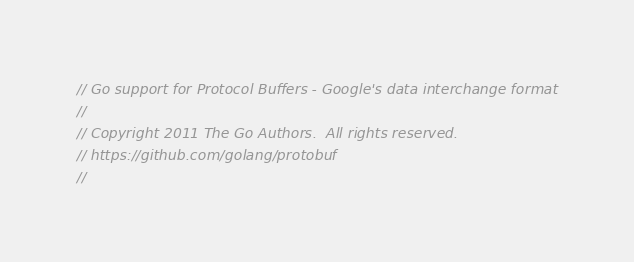Convert code to text. <code><loc_0><loc_0><loc_500><loc_500><_Go_>// Go support for Protocol Buffers - Google's data interchange format
//
// Copyright 2011 The Go Authors.  All rights reserved.
// https://github.com/golang/protobuf
//</code> 